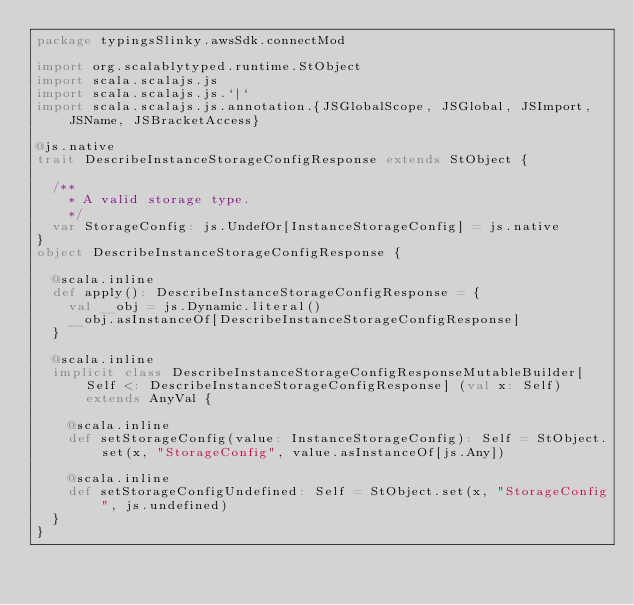<code> <loc_0><loc_0><loc_500><loc_500><_Scala_>package typingsSlinky.awsSdk.connectMod

import org.scalablytyped.runtime.StObject
import scala.scalajs.js
import scala.scalajs.js.`|`
import scala.scalajs.js.annotation.{JSGlobalScope, JSGlobal, JSImport, JSName, JSBracketAccess}

@js.native
trait DescribeInstanceStorageConfigResponse extends StObject {
  
  /**
    * A valid storage type.
    */
  var StorageConfig: js.UndefOr[InstanceStorageConfig] = js.native
}
object DescribeInstanceStorageConfigResponse {
  
  @scala.inline
  def apply(): DescribeInstanceStorageConfigResponse = {
    val __obj = js.Dynamic.literal()
    __obj.asInstanceOf[DescribeInstanceStorageConfigResponse]
  }
  
  @scala.inline
  implicit class DescribeInstanceStorageConfigResponseMutableBuilder[Self <: DescribeInstanceStorageConfigResponse] (val x: Self) extends AnyVal {
    
    @scala.inline
    def setStorageConfig(value: InstanceStorageConfig): Self = StObject.set(x, "StorageConfig", value.asInstanceOf[js.Any])
    
    @scala.inline
    def setStorageConfigUndefined: Self = StObject.set(x, "StorageConfig", js.undefined)
  }
}
</code> 